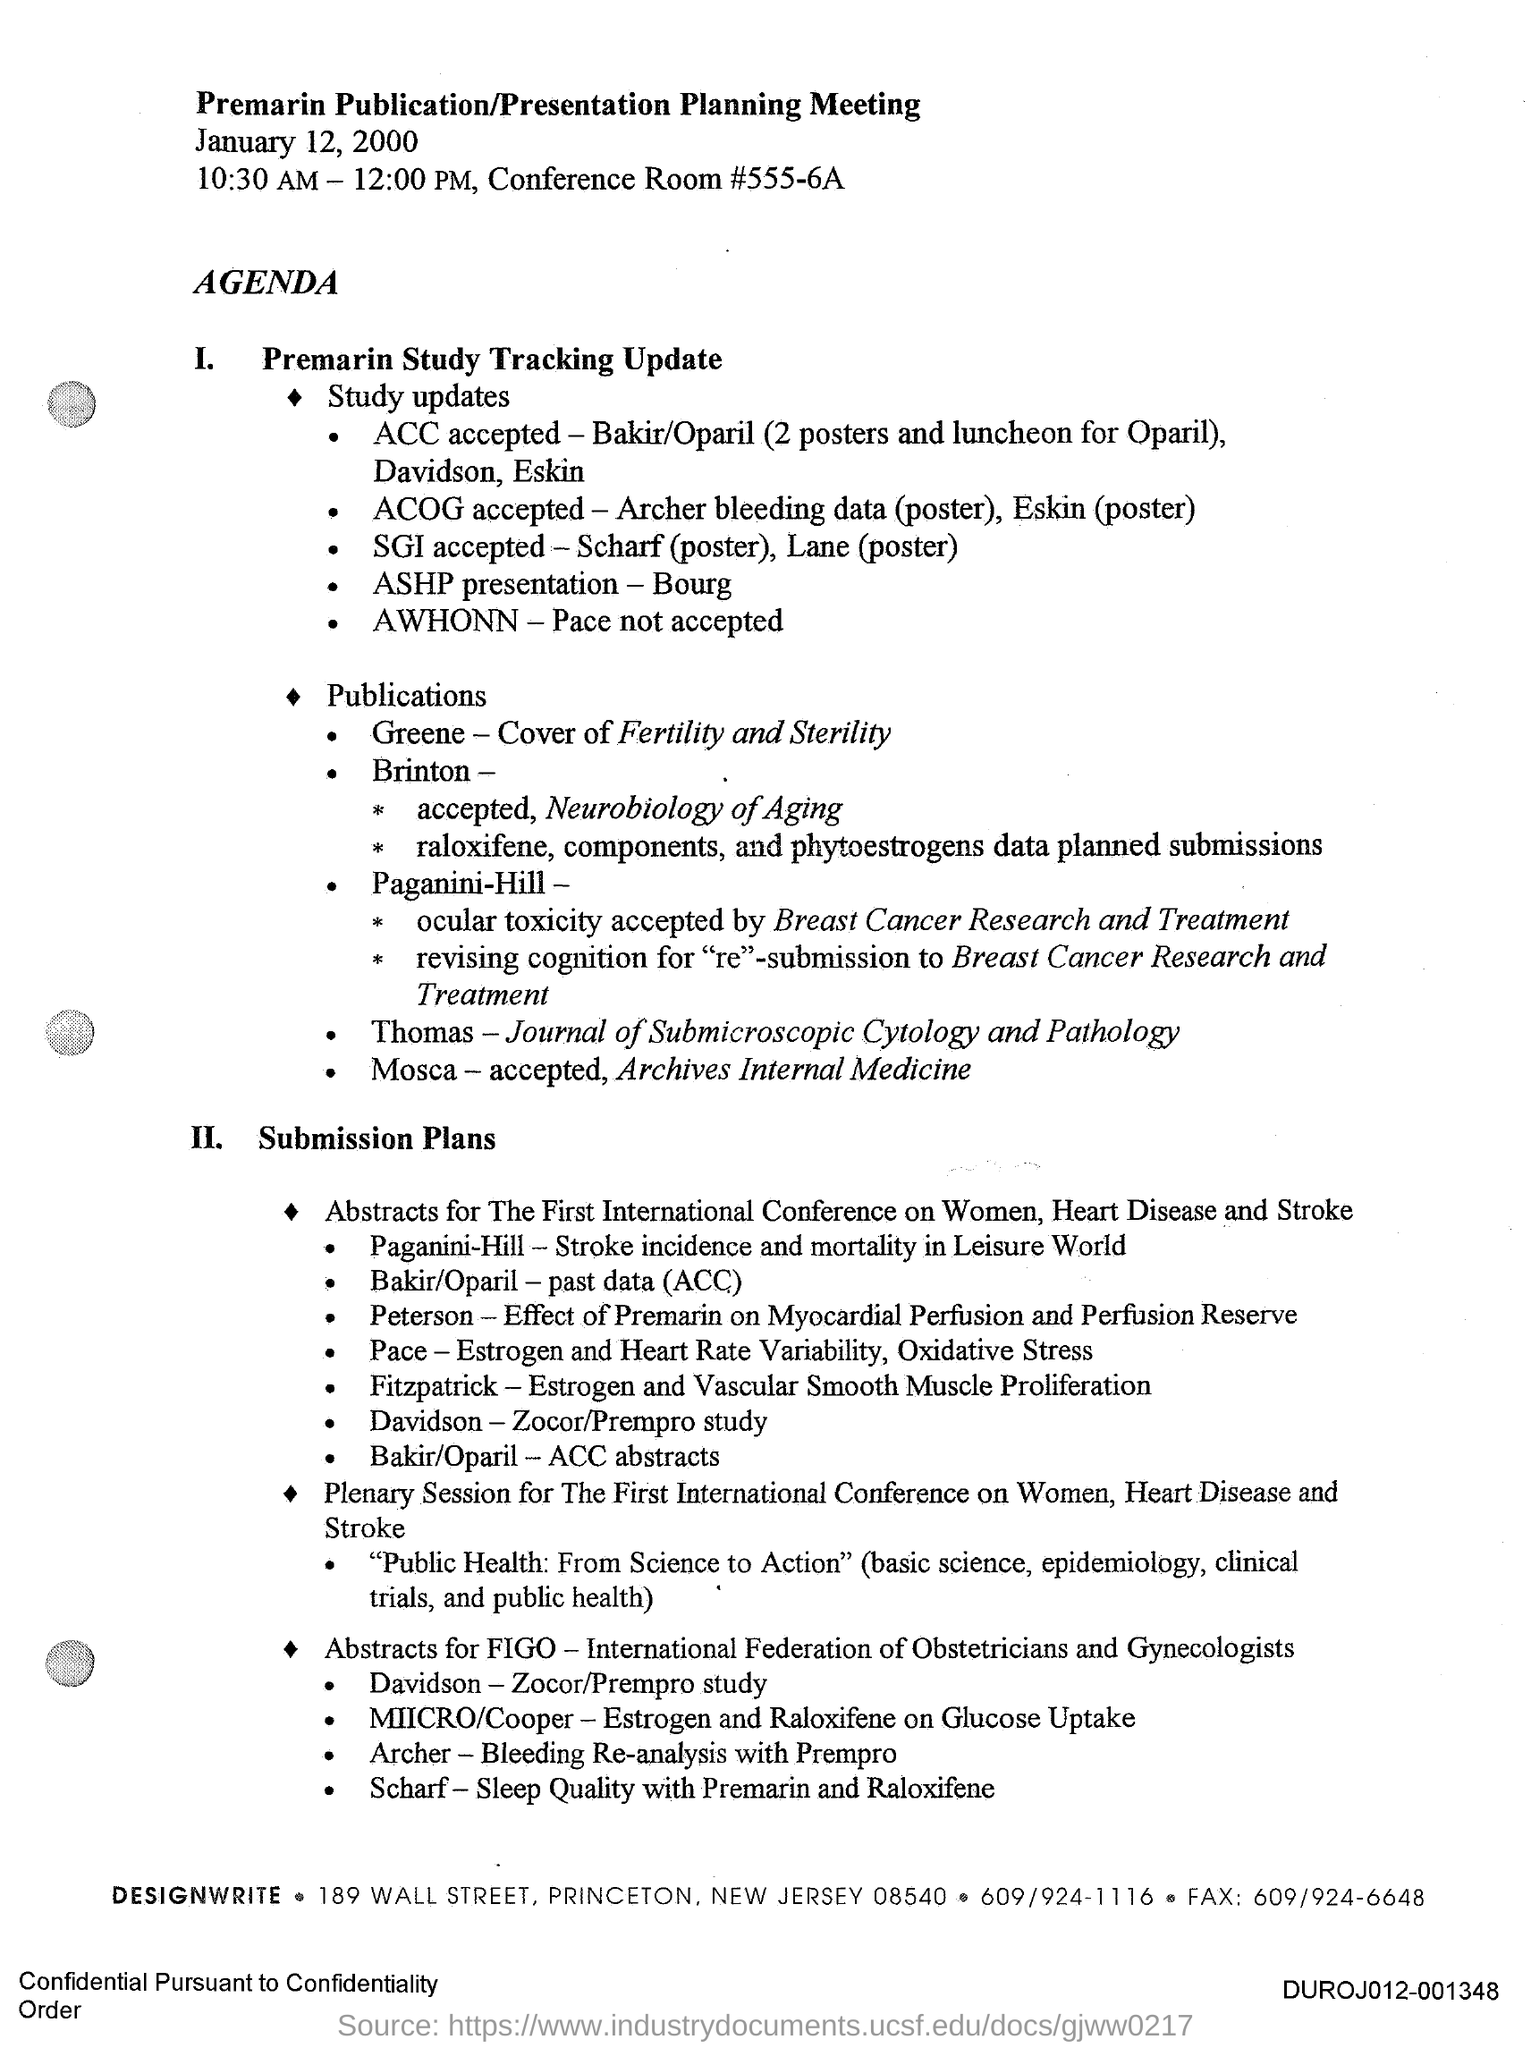Draw attention to some important aspects in this diagram. This is a premarin publication/presentation planning meeting. The fax number is 609/924-6648. The conference room number is 555-6A... The document provides the information that the date mentioned is January 12, 2000. 